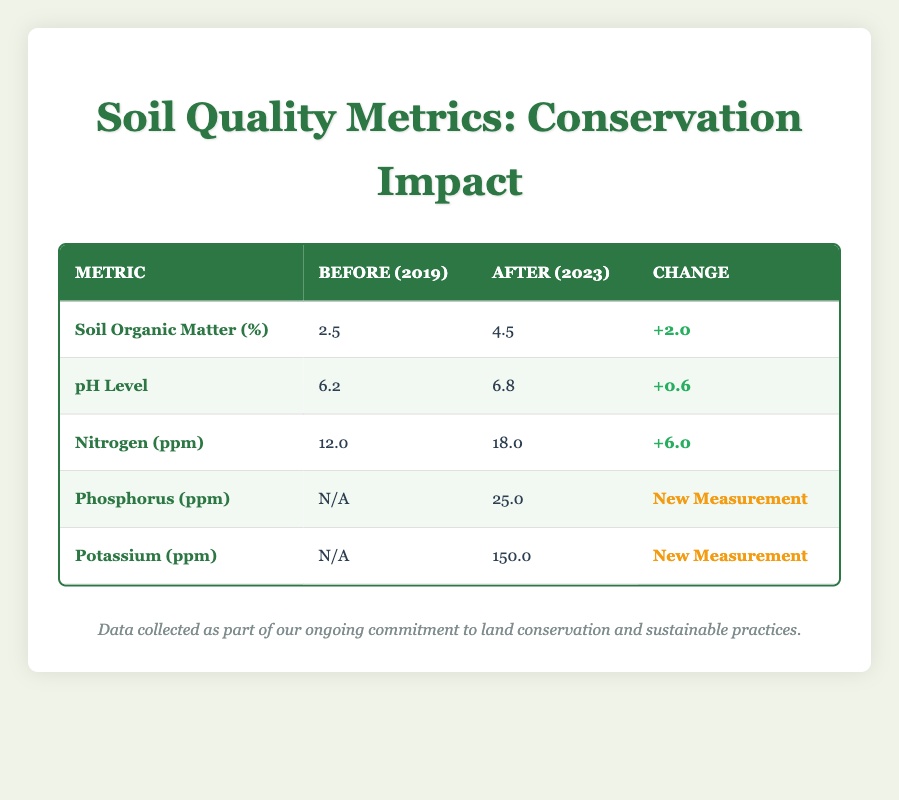What was the Soil Organic Matter percentage before the conservation efforts? According to the table, the Soil Organic Matter was 2.5% in 2019, which reflects the condition before conservation efforts began.
Answer: 2.5% What is the increase in pH Level from before to after conservation efforts? The pH Level increased from 6.2 in 2019 to 6.8 in 2023. The increase is calculated as 6.8 - 6.2 = 0.6.
Answer: 0.6 Is there a recorded nitrogen level before the conservation efforts? The table shows a nitrogen level of 12.0 ppm recorded in 2019, indicating that there was indeed a measurement before conservation initiatives.
Answer: Yes What were the levels of Phosphorus and Potassium after conservation efforts? The table indicates that after the conservation efforts in 2023, Phosphorus was measured at 25.0 ppm and Potassium at 150.0 ppm.
Answer: Phosphorus: 25.0 ppm, Potassium: 150.0 ppm What is the total increase in Nitrogen (ppm) from 2019 to 2023? The Nitrogen level increased from 12.0 ppm in 2019 to 18.0 ppm in 2023. The total increase is calculated as 18.0 - 12.0 = 6.0 ppm.
Answer: 6.0 ppm Did all soil quality metrics show improvement after conservation efforts? The table shows positive changes in Soil Organic Matter, pH Level, and Nitrogen, while Phosphorus and Potassium were new measurements, indicating improvement in several metrics but not all were measured before.
Answer: No What was the percentage increase in Soil Organic Matter from before to after conservation efforts? To find the percentage increase, we calculate (4.5 - 2.5) / 2.5 * 100 = 80%. This means Soil Organic Matter increased by 80% after conservation.
Answer: 80% Was the pH level neutral before the conservation efforts? A neutral pH level is typically around 7.0, and since the pH Level was 6.2 before conservation efforts, it was not neutral.
Answer: No How many soil quality metrics had data recorded before conservation efforts? The table lists three soil quality metrics (Soil Organic Matter, pH Level, and Nitrogen) with values recorded in 2019, meaning three metrics had data before the conservation efforts.
Answer: 3 